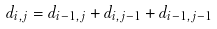Convert formula to latex. <formula><loc_0><loc_0><loc_500><loc_500>d _ { i , j } = d _ { i - 1 , j } + d _ { i , j - 1 } + d _ { i - 1 , j - 1 }</formula> 